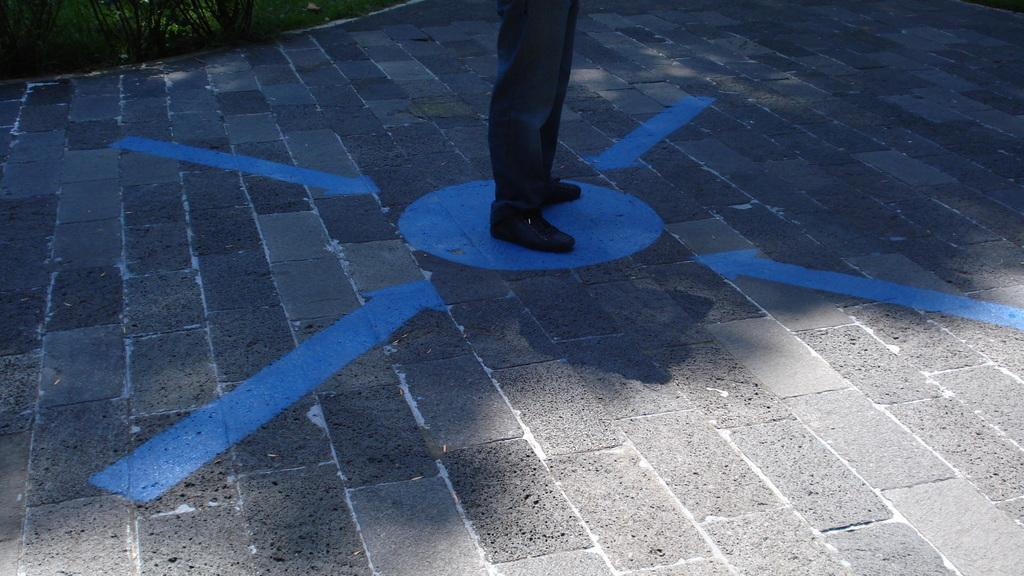Can you describe this image briefly? In this image we can see some plants and grass on the ground. There is one road painted with blue color arrows and circle. Person legs with black shoes on the circle. 